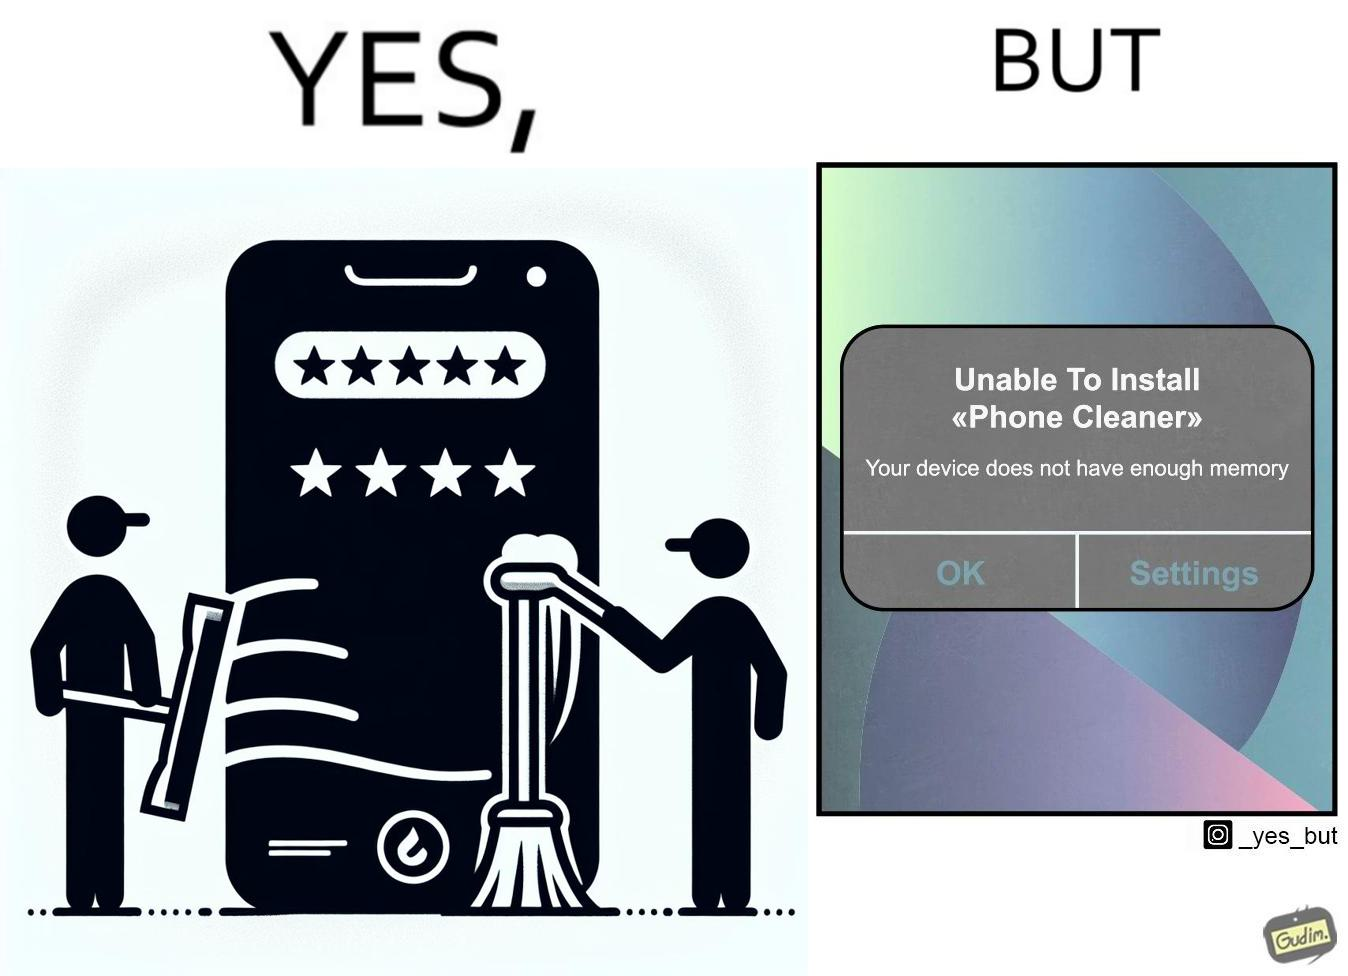Is there satirical content in this image? Yes, this image is satirical. 